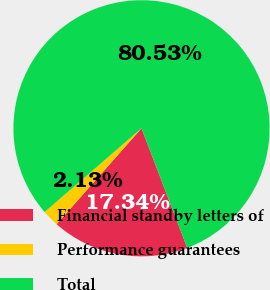Convert chart. <chart><loc_0><loc_0><loc_500><loc_500><pie_chart><fcel>Financial standby letters of<fcel>Performance guarantees<fcel>Total<nl><fcel>17.34%<fcel>2.13%<fcel>80.53%<nl></chart> 